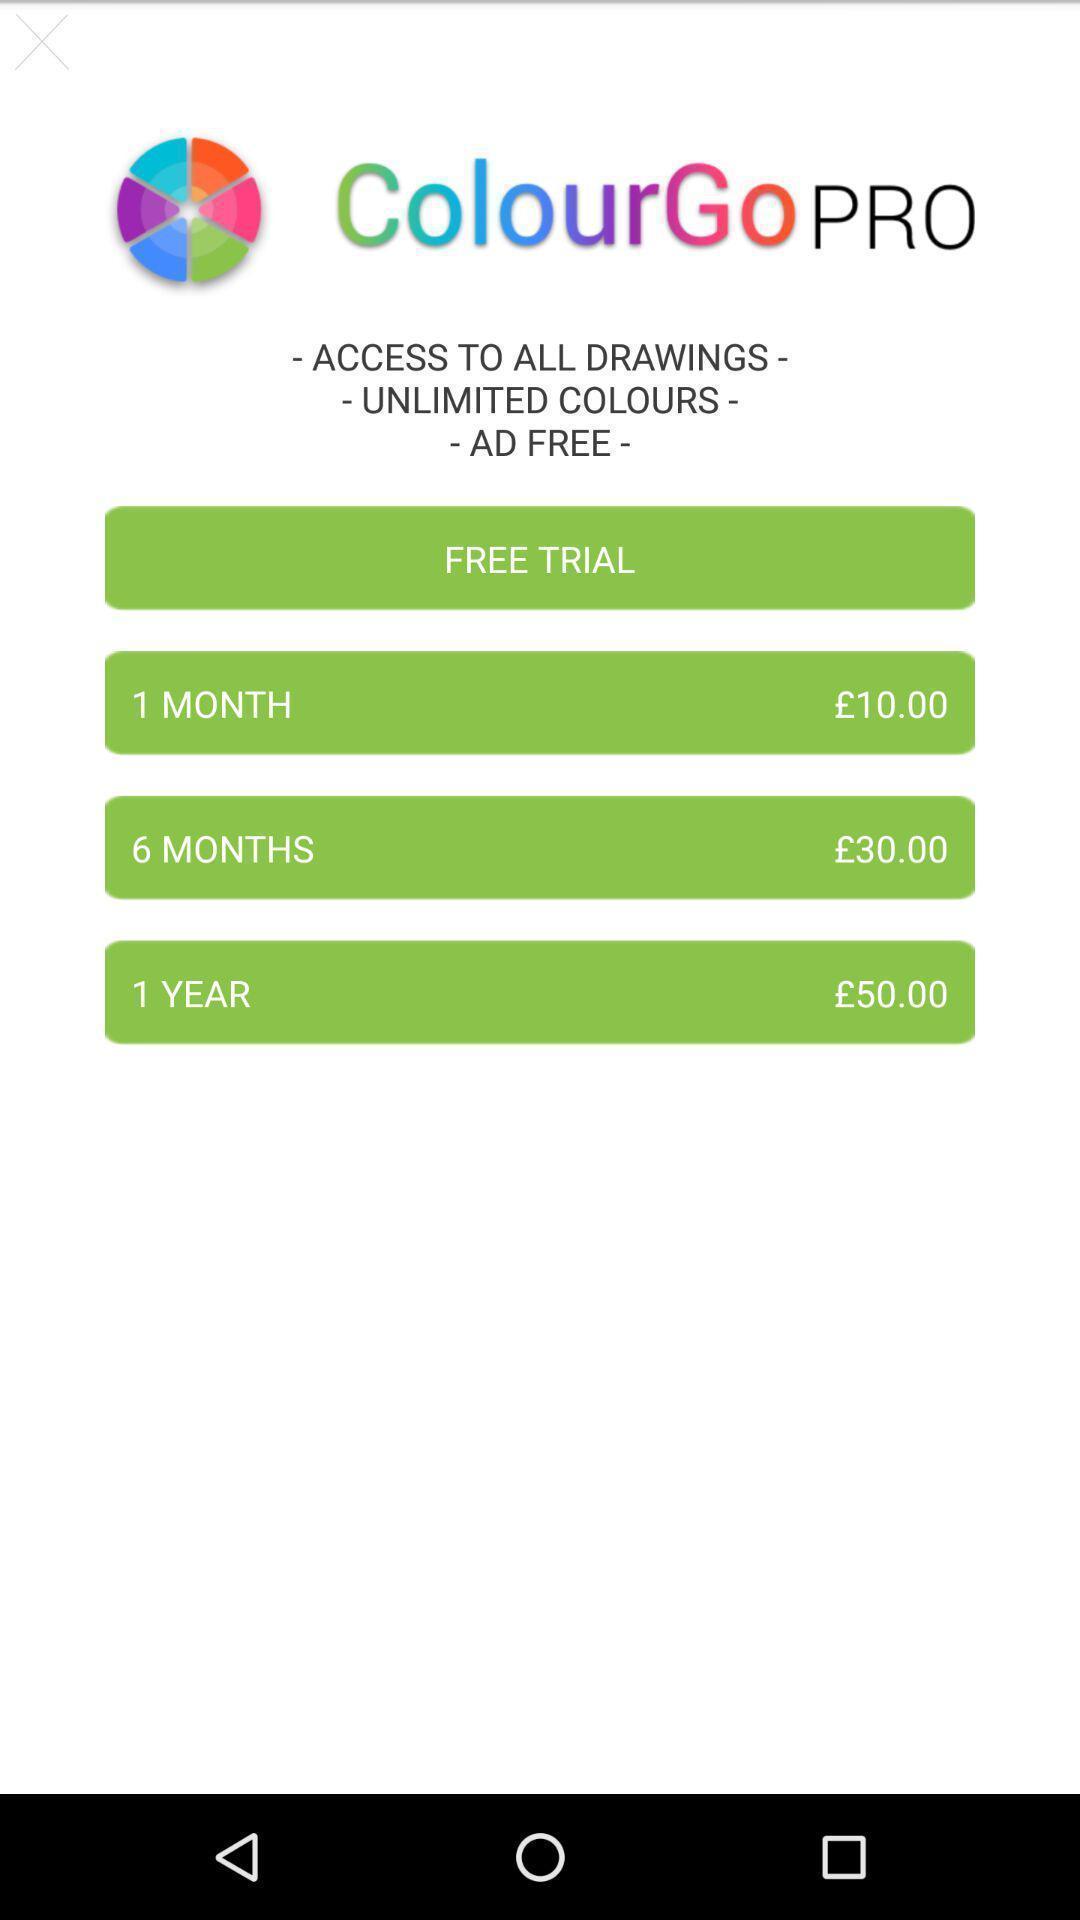Describe the visual elements of this screenshot. Screen displaying page with options. 